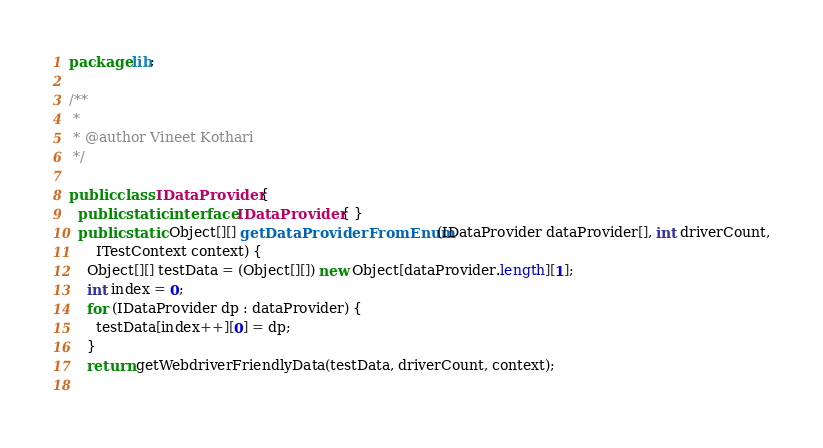Convert code to text. <code><loc_0><loc_0><loc_500><loc_500><_Java_>package lib;

/**
 *
 * @author Vineet Kothari
 */

public class IDataProvider {
  public static interface IDataProvider { }
  public static Object[][] getDataProviderFromEnum(IDataProvider dataProvider[], int driverCount,
      ITestContext context) {
    Object[][] testData = (Object[][]) new Object[dataProvider.length][1];
    int index = 0;
    for (IDataProvider dp : dataProvider) {
      testData[index++][0] = dp;
    }
    return getWebdriverFriendlyData(testData, driverCount, context);
  
</code> 